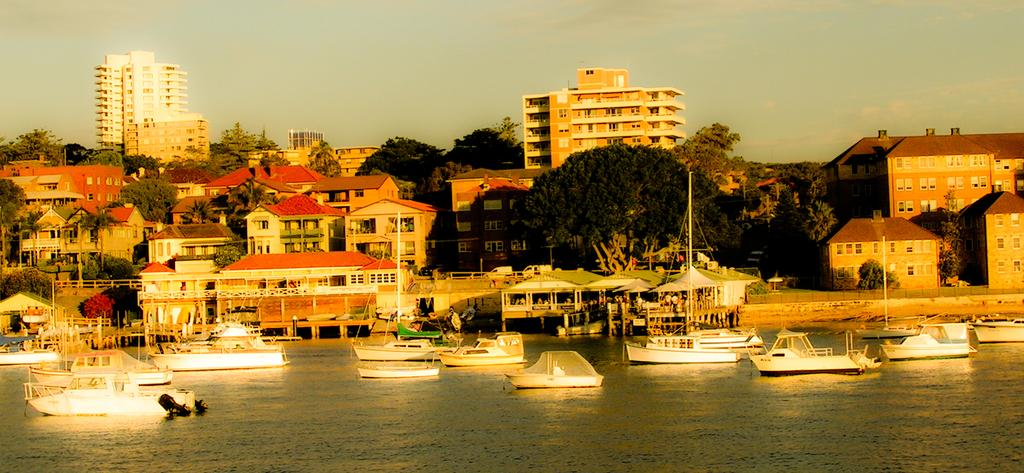What is on the water in the image? There are boats on the water in the image. What structure is present in the image? There is a deck in the image. What can be seen in the background of the image? Buildings, trees, poles, roads, fences, and the sky are visible in the background of the image. What type of clouds can be seen on the elbow of the person in the image? There is no person present in the image, and therefore no elbow or clouds on it. What kind of board is being used by the person in the image? There is no person present in the image, and therefore no board being used. 